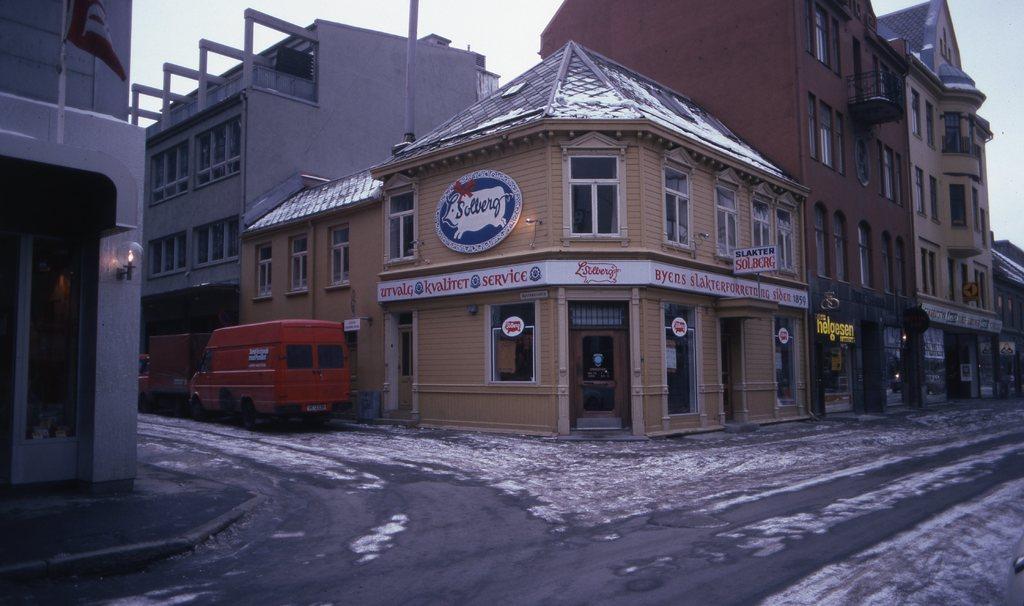Can you describe this image briefly? In this image we can see few buildings, vehicles on the road, there is a light to the building, boards attached to the buildings and the sky in the background. 